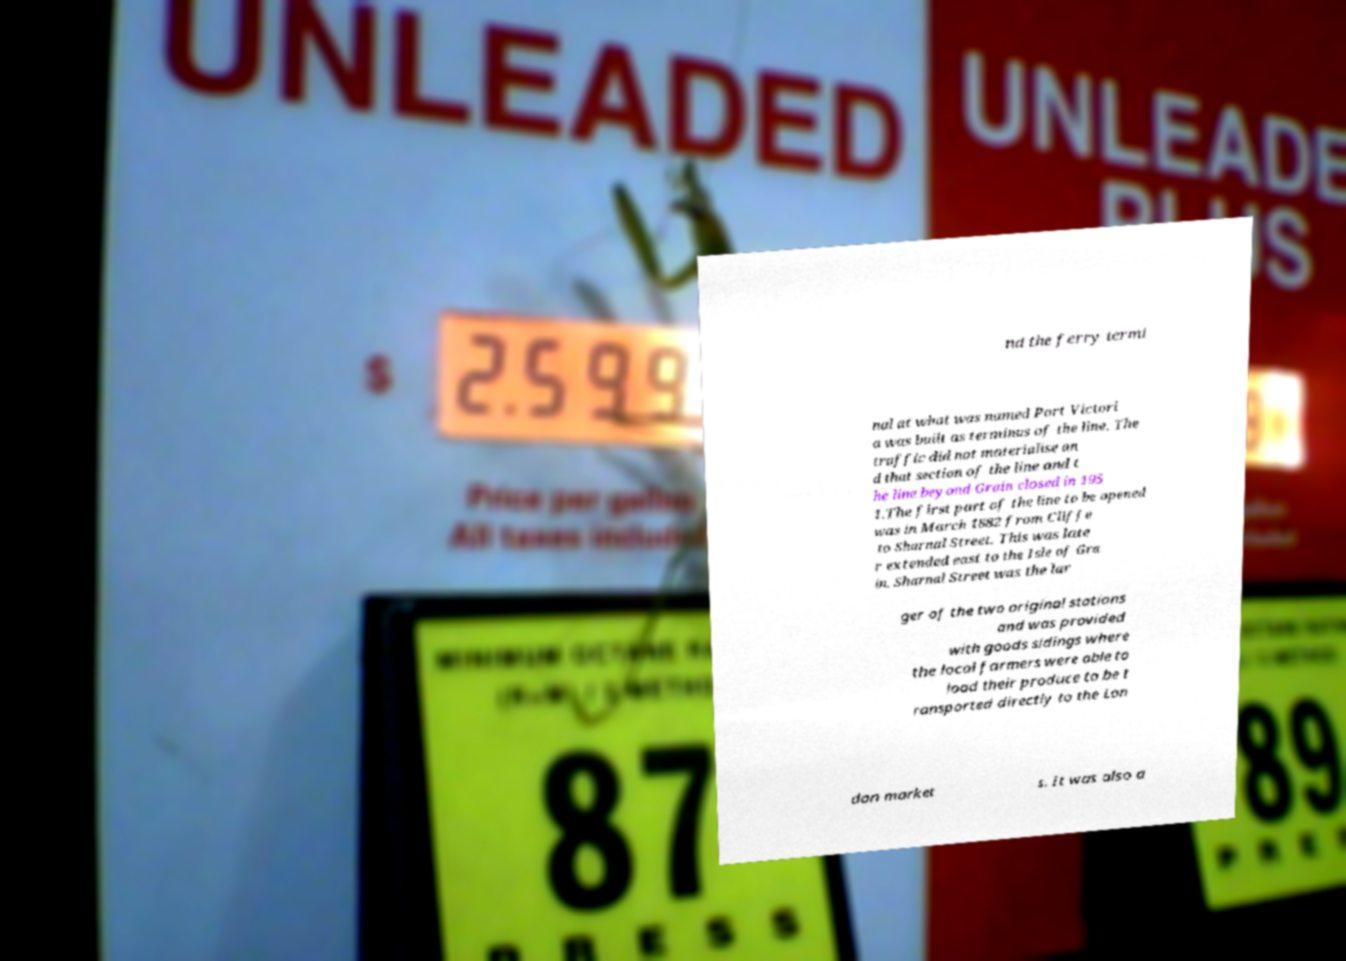Please identify and transcribe the text found in this image. nd the ferry termi nal at what was named Port Victori a was built as terminus of the line. The traffic did not materialise an d that section of the line and t he line beyond Grain closed in 195 1.The first part of the line to be opened was in March 1882 from Cliffe to Sharnal Street. This was late r extended east to the Isle of Gra in. Sharnal Street was the lar ger of the two original stations and was provided with goods sidings where the local farmers were able to load their produce to be t ransported directly to the Lon don market s. It was also a 